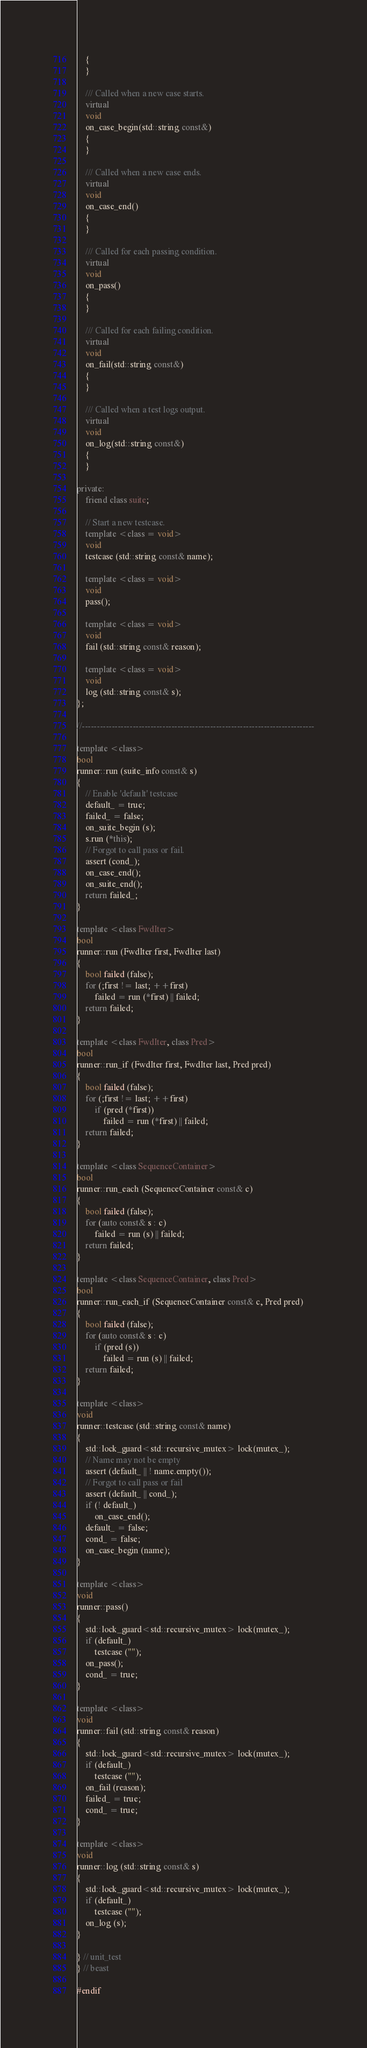Convert code to text. <code><loc_0><loc_0><loc_500><loc_500><_C++_>    {
    }

    /// Called when a new case starts.
    virtual
    void
    on_case_begin(std::string const&)
    {
    }

    /// Called when a new case ends.
    virtual
    void
    on_case_end()
    {
    }

    /// Called for each passing condition.
    virtual
    void
    on_pass()
    {
    }

    /// Called for each failing condition.
    virtual
    void
    on_fail(std::string const&)
    {
    }

    /// Called when a test logs output.
    virtual
    void
    on_log(std::string const&)
    {
    }

private:
    friend class suite;

    // Start a new testcase.
    template <class = void>
    void
    testcase (std::string const& name);

    template <class = void>
    void
    pass();

    template <class = void>
    void
    fail (std::string const& reason);

    template <class = void>
    void
    log (std::string const& s);
};

//------------------------------------------------------------------------------

template <class>
bool
runner::run (suite_info const& s)
{
    // Enable 'default' testcase
    default_ = true;
    failed_ = false;
    on_suite_begin (s);
    s.run (*this);
    // Forgot to call pass or fail.
    assert (cond_);
    on_case_end();
    on_suite_end();
    return failed_;
}

template <class FwdIter>
bool
runner::run (FwdIter first, FwdIter last)
{
    bool failed (false);
    for (;first != last; ++first)
        failed = run (*first) || failed;
    return failed;
}

template <class FwdIter, class Pred>
bool
runner::run_if (FwdIter first, FwdIter last, Pred pred)
{
    bool failed (false);
    for (;first != last; ++first)
        if (pred (*first))
            failed = run (*first) || failed;
    return failed;
}

template <class SequenceContainer>
bool
runner::run_each (SequenceContainer const& c)
{
    bool failed (false);
    for (auto const& s : c)
        failed = run (s) || failed;
    return failed;
}

template <class SequenceContainer, class Pred>
bool
runner::run_each_if (SequenceContainer const& c, Pred pred)
{
    bool failed (false);
    for (auto const& s : c)
        if (pred (s))
            failed = run (s) || failed;
    return failed;
}

template <class>
void
runner::testcase (std::string const& name)
{
    std::lock_guard<std::recursive_mutex> lock(mutex_);
    // Name may not be empty
    assert (default_ || ! name.empty());
    // Forgot to call pass or fail
    assert (default_ || cond_);
    if (! default_)
        on_case_end();
    default_ = false;
    cond_ = false;
    on_case_begin (name);
}

template <class>
void
runner::pass()
{
    std::lock_guard<std::recursive_mutex> lock(mutex_);
    if (default_)
        testcase ("");
    on_pass();
    cond_ = true;
}

template <class>
void
runner::fail (std::string const& reason)
{
    std::lock_guard<std::recursive_mutex> lock(mutex_);
    if (default_)
        testcase ("");
    on_fail (reason);
    failed_ = true;
    cond_ = true;
}

template <class>
void
runner::log (std::string const& s)
{
    std::lock_guard<std::recursive_mutex> lock(mutex_);
    if (default_)
        testcase ("");
    on_log (s);
}

} // unit_test
} // beast

#endif
</code> 